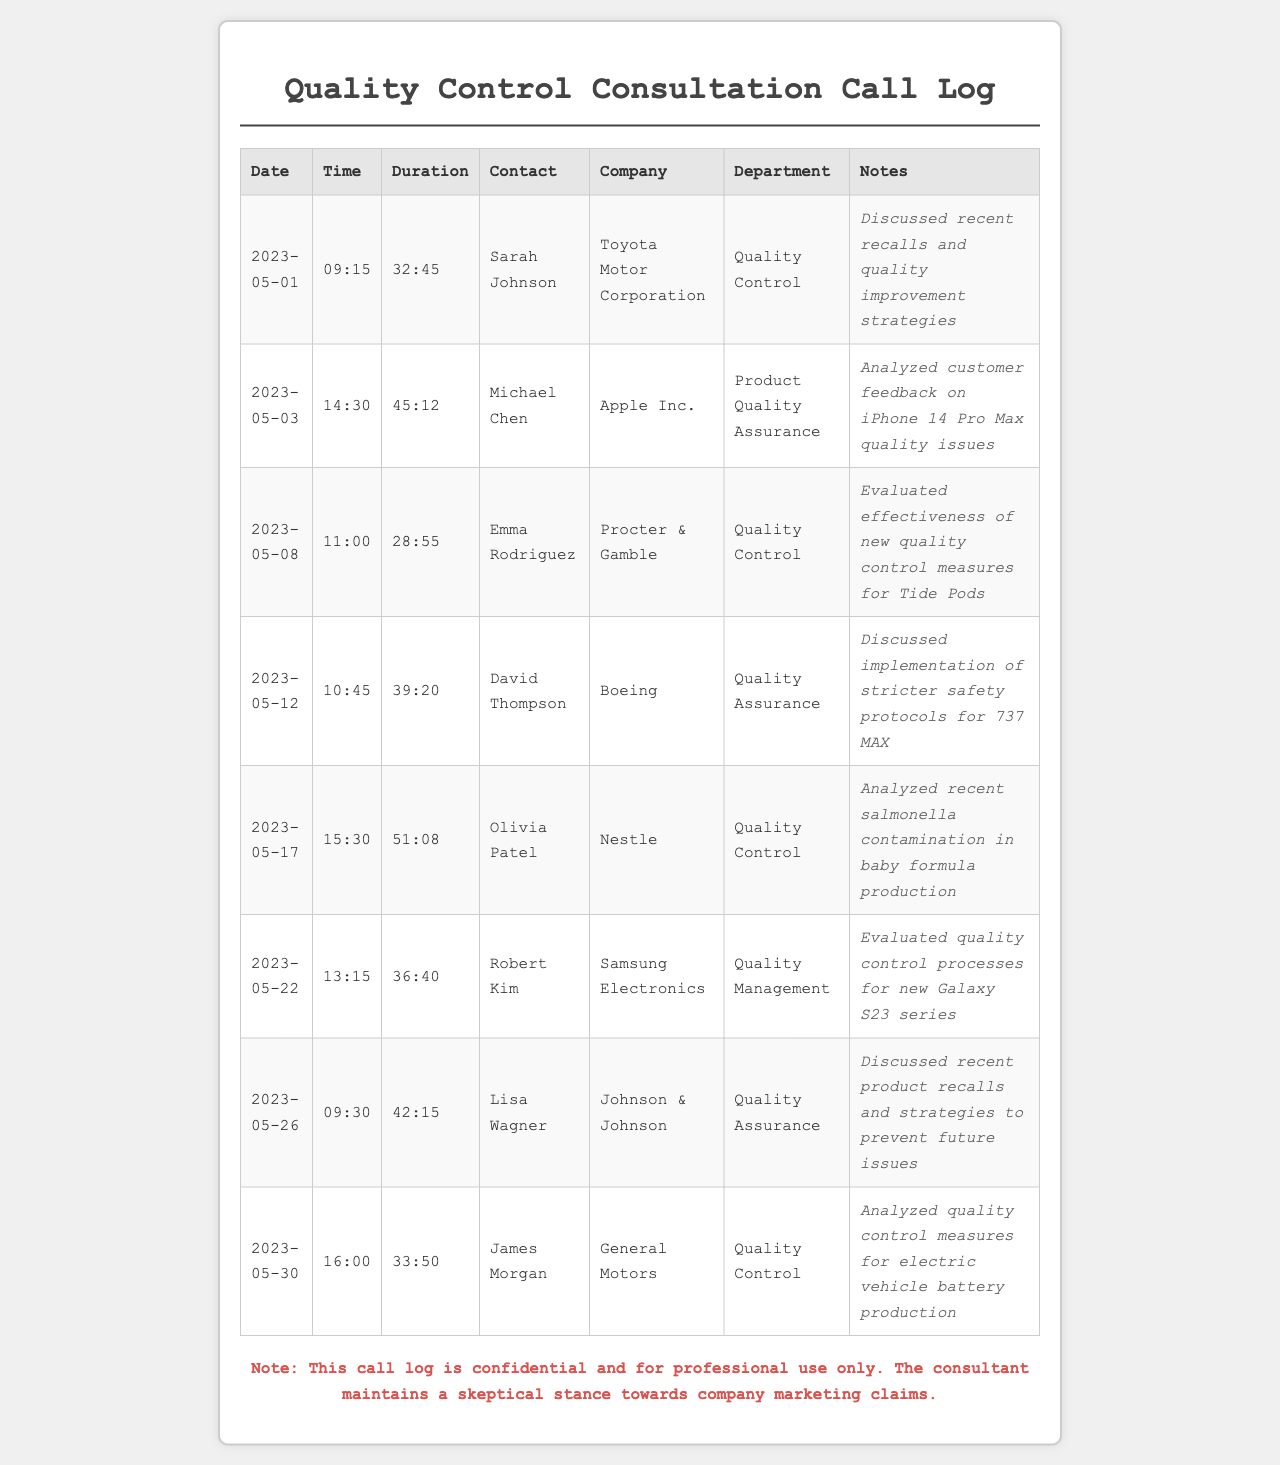what was the longest call duration? The longest call duration can be found by comparing the durations listed in the document, which is 51:08.
Answer: 51:08 who was contacted on May 12? The contact on May 12 is listed in the document as David Thompson.
Answer: David Thompson which company had a discussion about quality issues related to iPhone 14 Pro Max? The document specifies that Apple Inc. had discussions regarding the iPhone 14 Pro Max quality issues.
Answer: Apple Inc how many calls were made to Toyota Motor Corporation? By counting the entries in the document, it is evident that there was one call made to Toyota Motor Corporation.
Answer: 1 what was the date of the call with Procter & Gamble? The date of the call with Procter & Gamble is provided as May 8.
Answer: May 8 which department did Olivia Patel belong to? The document indicates that Olivia Patel was part of the Quality Control department.
Answer: Quality Control what was discussed during the call with Samsung Electronics? The notes from the call with Samsung Electronics indicate that quality control processes for the new Galaxy S23 series were evaluated.
Answer: Quality control processes for new Galaxy S23 series how many calls involved discussions about product recalls? There were two calls specifically involving discussions about product recalls as noted in the document.
Answer: 2 what time was the call with General Motors? The time of the call with General Motors is specified in the document as 16:00.
Answer: 16:00 